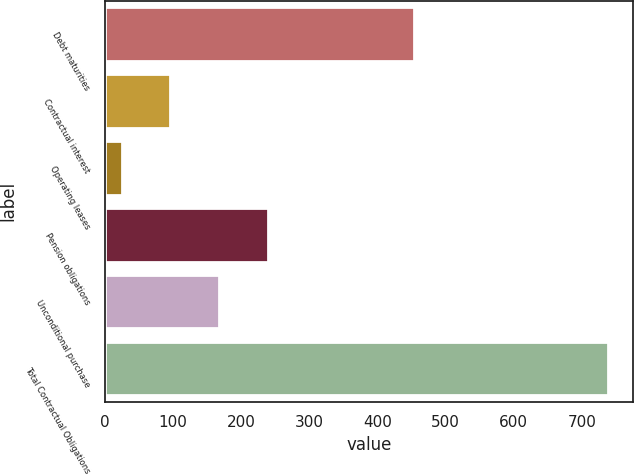<chart> <loc_0><loc_0><loc_500><loc_500><bar_chart><fcel>Debt maturities<fcel>Contractual interest<fcel>Operating leases<fcel>Pension obligations<fcel>Unconditional purchase<fcel>Total Contractual Obligations<nl><fcel>454<fcel>96.3<fcel>25<fcel>238.9<fcel>167.6<fcel>738<nl></chart> 